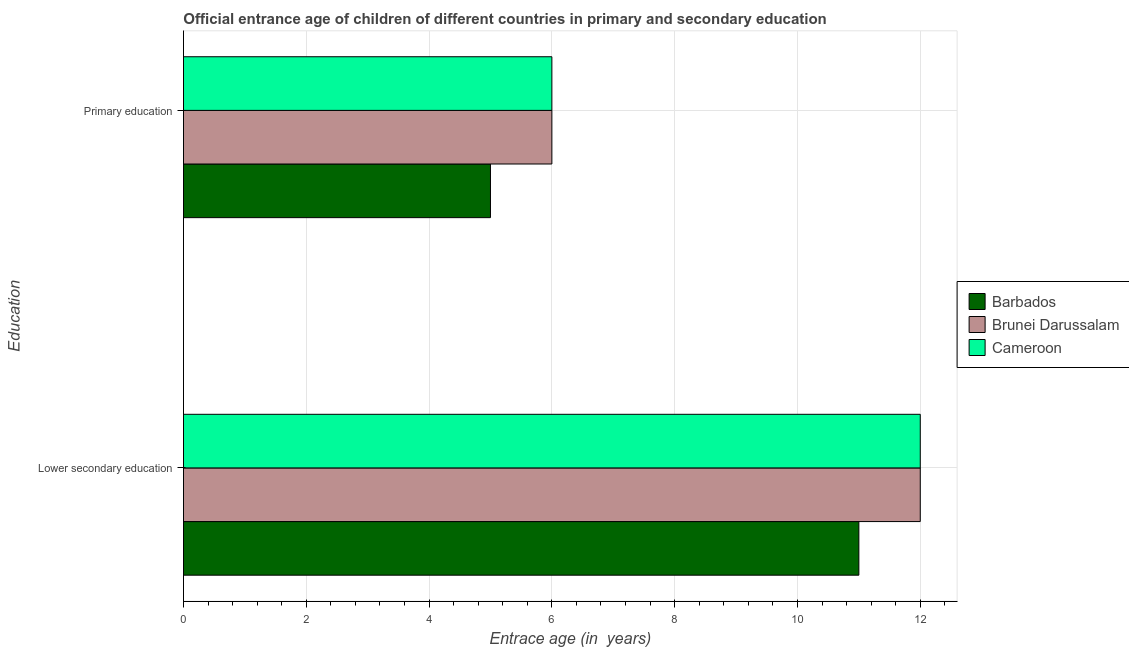How many different coloured bars are there?
Your response must be concise. 3. How many groups of bars are there?
Provide a short and direct response. 2. Are the number of bars per tick equal to the number of legend labels?
Provide a short and direct response. Yes. Are the number of bars on each tick of the Y-axis equal?
Offer a very short reply. Yes. How many bars are there on the 2nd tick from the top?
Provide a succinct answer. 3. How many bars are there on the 2nd tick from the bottom?
Offer a very short reply. 3. What is the entrance age of children in lower secondary education in Brunei Darussalam?
Ensure brevity in your answer.  12. Across all countries, what is the maximum entrance age of children in lower secondary education?
Ensure brevity in your answer.  12. Across all countries, what is the minimum entrance age of children in lower secondary education?
Keep it short and to the point. 11. In which country was the entrance age of chiildren in primary education maximum?
Your answer should be very brief. Brunei Darussalam. In which country was the entrance age of children in lower secondary education minimum?
Provide a succinct answer. Barbados. What is the total entrance age of children in lower secondary education in the graph?
Provide a succinct answer. 35. What is the difference between the entrance age of chiildren in primary education in Cameroon and that in Brunei Darussalam?
Your answer should be compact. 0. What is the difference between the entrance age of chiildren in primary education in Brunei Darussalam and the entrance age of children in lower secondary education in Cameroon?
Make the answer very short. -6. What is the average entrance age of children in lower secondary education per country?
Provide a succinct answer. 11.67. What is the difference between the entrance age of children in lower secondary education and entrance age of chiildren in primary education in Brunei Darussalam?
Provide a short and direct response. 6. What is the ratio of the entrance age of children in lower secondary education in Cameroon to that in Barbados?
Make the answer very short. 1.09. What does the 2nd bar from the top in Lower secondary education represents?
Your answer should be very brief. Brunei Darussalam. What does the 1st bar from the bottom in Lower secondary education represents?
Give a very brief answer. Barbados. Are all the bars in the graph horizontal?
Offer a terse response. Yes. How many countries are there in the graph?
Your answer should be very brief. 3. What is the difference between two consecutive major ticks on the X-axis?
Offer a very short reply. 2. Are the values on the major ticks of X-axis written in scientific E-notation?
Make the answer very short. No. Does the graph contain grids?
Your answer should be very brief. Yes. Where does the legend appear in the graph?
Your response must be concise. Center right. What is the title of the graph?
Give a very brief answer. Official entrance age of children of different countries in primary and secondary education. Does "Djibouti" appear as one of the legend labels in the graph?
Your answer should be compact. No. What is the label or title of the X-axis?
Provide a succinct answer. Entrace age (in  years). What is the label or title of the Y-axis?
Offer a very short reply. Education. What is the Entrace age (in  years) of Barbados in Lower secondary education?
Your answer should be very brief. 11. What is the Entrace age (in  years) of Cameroon in Lower secondary education?
Give a very brief answer. 12. What is the Entrace age (in  years) of Cameroon in Primary education?
Give a very brief answer. 6. Across all Education, what is the maximum Entrace age (in  years) of Barbados?
Your answer should be very brief. 11. Across all Education, what is the maximum Entrace age (in  years) of Brunei Darussalam?
Ensure brevity in your answer.  12. Across all Education, what is the minimum Entrace age (in  years) in Barbados?
Offer a terse response. 5. What is the total Entrace age (in  years) in Barbados in the graph?
Your answer should be compact. 16. What is the total Entrace age (in  years) of Cameroon in the graph?
Provide a succinct answer. 18. What is the difference between the Entrace age (in  years) in Brunei Darussalam in Lower secondary education and that in Primary education?
Keep it short and to the point. 6. What is the difference between the Entrace age (in  years) of Cameroon in Lower secondary education and that in Primary education?
Provide a short and direct response. 6. What is the difference between the Entrace age (in  years) of Barbados in Lower secondary education and the Entrace age (in  years) of Brunei Darussalam in Primary education?
Offer a terse response. 5. What is the difference between the Entrace age (in  years) in Barbados in Lower secondary education and the Entrace age (in  years) in Cameroon in Primary education?
Your answer should be compact. 5. What is the difference between the Entrace age (in  years) in Barbados and Entrace age (in  years) in Brunei Darussalam in Primary education?
Your response must be concise. -1. What is the ratio of the Entrace age (in  years) in Barbados in Lower secondary education to that in Primary education?
Make the answer very short. 2.2. What is the ratio of the Entrace age (in  years) in Brunei Darussalam in Lower secondary education to that in Primary education?
Ensure brevity in your answer.  2. What is the ratio of the Entrace age (in  years) in Cameroon in Lower secondary education to that in Primary education?
Offer a terse response. 2. What is the difference between the highest and the second highest Entrace age (in  years) of Cameroon?
Keep it short and to the point. 6. 